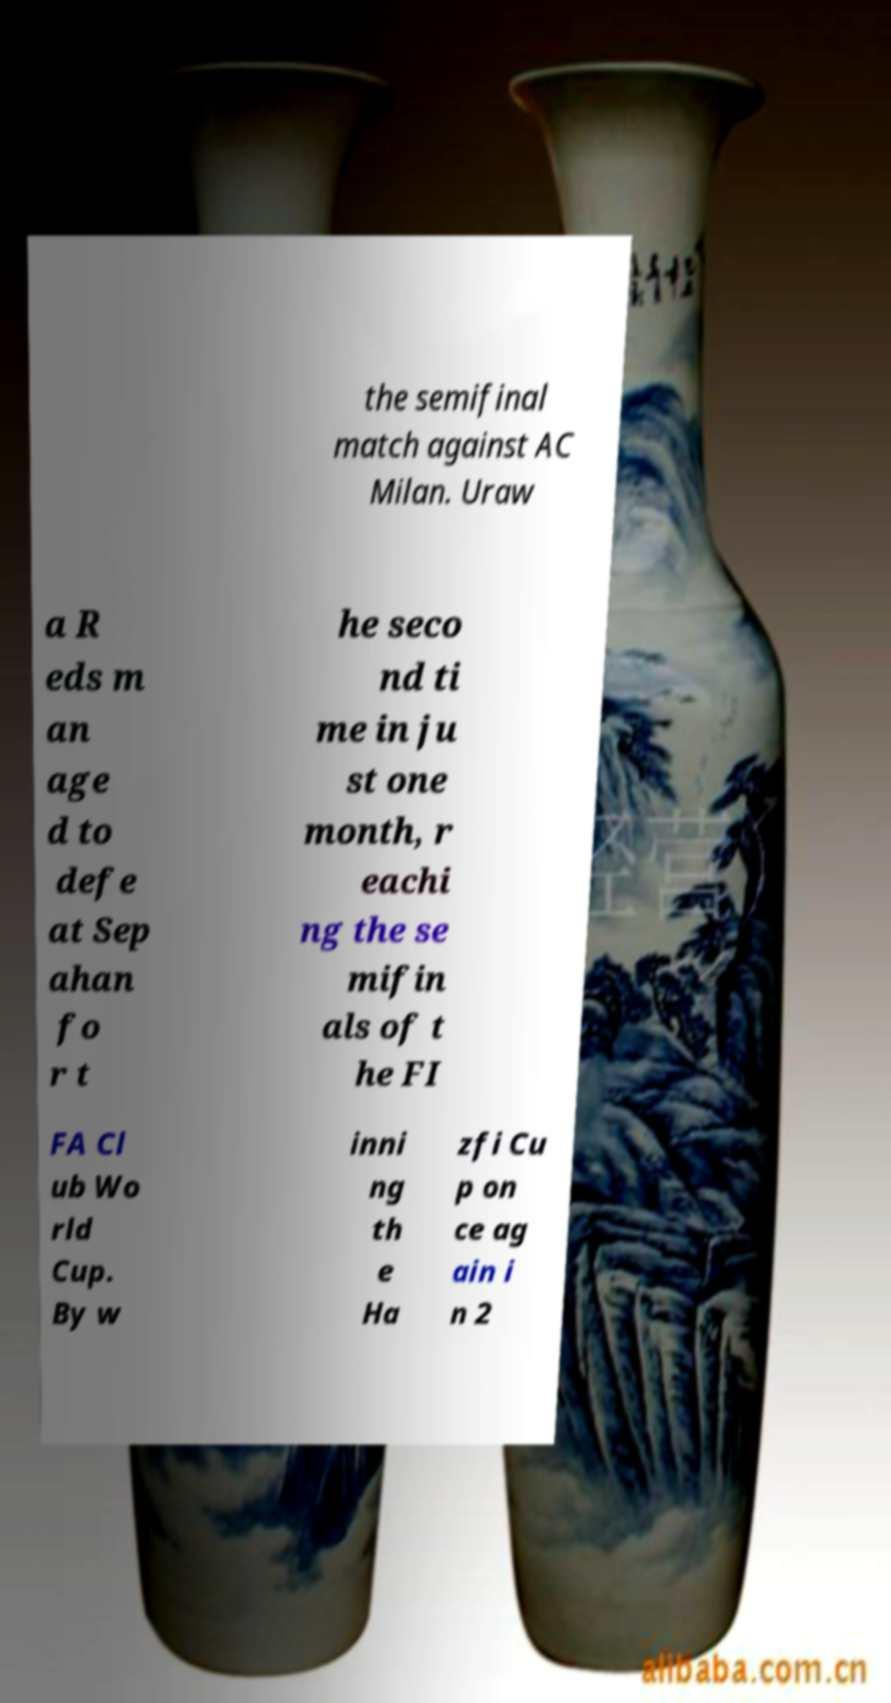For documentation purposes, I need the text within this image transcribed. Could you provide that? the semifinal match against AC Milan. Uraw a R eds m an age d to defe at Sep ahan fo r t he seco nd ti me in ju st one month, r eachi ng the se mifin als of t he FI FA Cl ub Wo rld Cup. By w inni ng th e Ha zfi Cu p on ce ag ain i n 2 